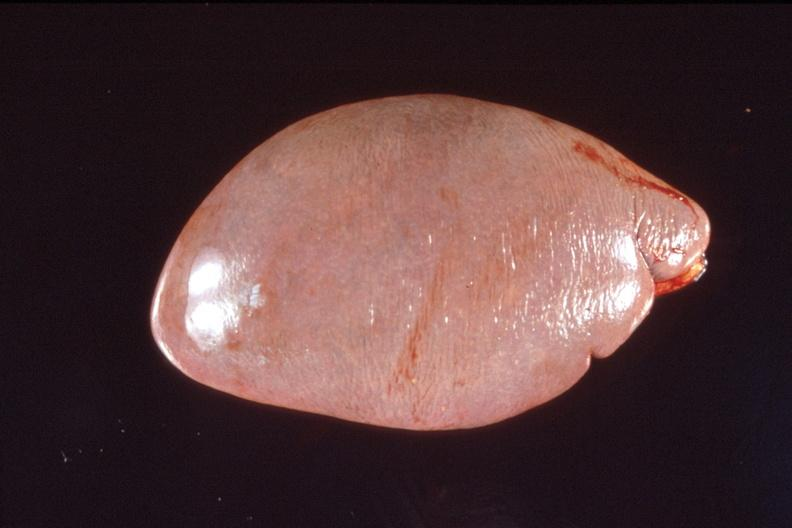what is present?
Answer the question using a single word or phrase. Hematologic 